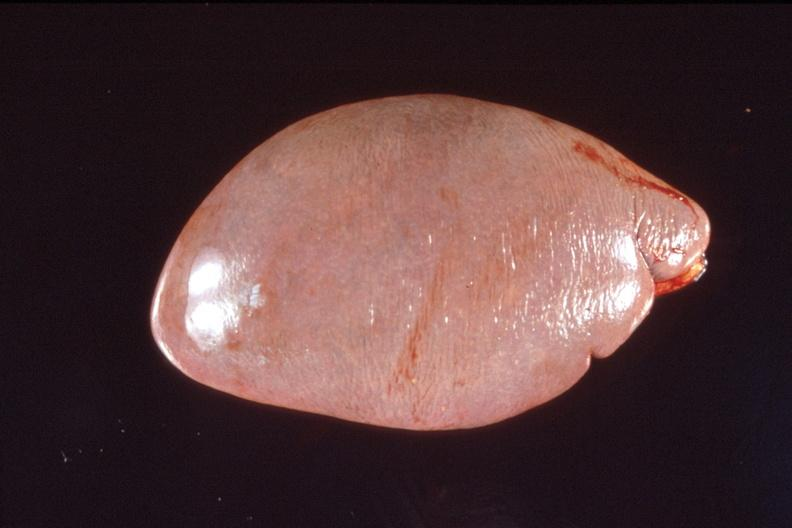what is present?
Answer the question using a single word or phrase. Hematologic 